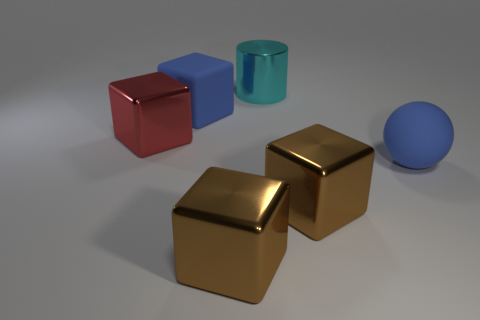Subtract all metallic cubes. How many cubes are left? 1 Subtract all brown blocks. How many blocks are left? 2 Subtract all balls. How many objects are left? 5 Add 1 big cyan objects. How many objects exist? 7 Subtract 1 balls. How many balls are left? 0 Subtract all red cylinders. Subtract all shiny things. How many objects are left? 2 Add 2 blue balls. How many blue balls are left? 3 Add 1 large red spheres. How many large red spheres exist? 1 Subtract 0 red cylinders. How many objects are left? 6 Subtract all gray balls. Subtract all gray cubes. How many balls are left? 1 